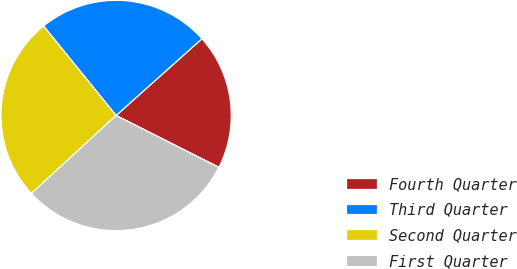Convert chart to OTSL. <chart><loc_0><loc_0><loc_500><loc_500><pie_chart><fcel>Fourth Quarter<fcel>Third Quarter<fcel>Second Quarter<fcel>First Quarter<nl><fcel>19.05%<fcel>24.23%<fcel>26.0%<fcel>30.72%<nl></chart> 